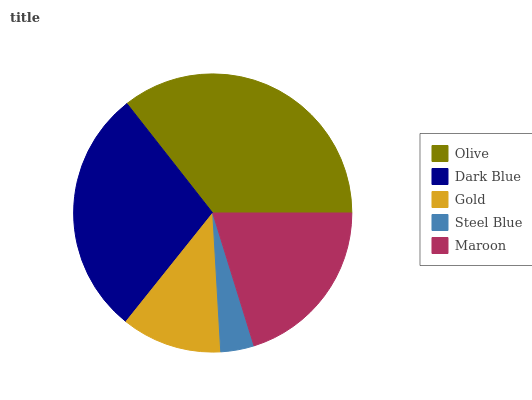Is Steel Blue the minimum?
Answer yes or no. Yes. Is Olive the maximum?
Answer yes or no. Yes. Is Dark Blue the minimum?
Answer yes or no. No. Is Dark Blue the maximum?
Answer yes or no. No. Is Olive greater than Dark Blue?
Answer yes or no. Yes. Is Dark Blue less than Olive?
Answer yes or no. Yes. Is Dark Blue greater than Olive?
Answer yes or no. No. Is Olive less than Dark Blue?
Answer yes or no. No. Is Maroon the high median?
Answer yes or no. Yes. Is Maroon the low median?
Answer yes or no. Yes. Is Dark Blue the high median?
Answer yes or no. No. Is Dark Blue the low median?
Answer yes or no. No. 